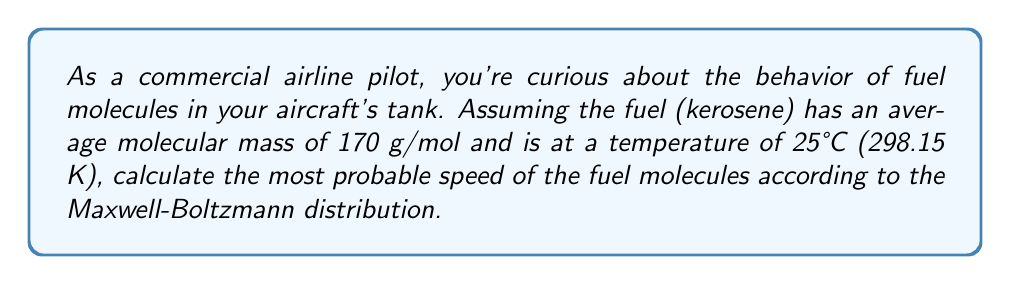Provide a solution to this math problem. To solve this problem, we'll use the Maxwell-Boltzmann distribution to find the most probable speed of the fuel molecules. Let's break it down step-by-step:

1. The formula for the most probable speed ($v_p$) in the Maxwell-Boltzmann distribution is:

   $$v_p = \sqrt{\frac{2k_BT}{m}}$$

   Where:
   $k_B$ is the Boltzmann constant
   $T$ is the temperature in Kelvin
   $m$ is the mass of a single molecule

2. We know:
   - Temperature, $T = 298.15$ K
   - Average molecular mass = 170 g/mol

3. First, let's convert the molecular mass to kilograms per molecule:
   $$m = \frac{170 \text{ g/mol}}{6.022 \times 10^{23} \text{ molecules/mol}} = 2.823 \times 10^{-22} \text{ kg/molecule}$$

4. Now, let's plug in the values:
   - $k_B = 1.380649 \times 10^{-23}$ J/K
   - $T = 298.15$ K
   - $m = 2.823 \times 10^{-22}$ kg

5. Calculating $v_p$:

   $$v_p = \sqrt{\frac{2(1.380649 \times 10^{-23} \text{ J/K})(298.15 \text{ K})}{2.823 \times 10^{-22} \text{ kg}}}$$

6. Simplifying:

   $$v_p = \sqrt{\frac{8.23 \times 10^{-21}}{2.823 \times 10^{-22}}}$$

   $$v_p = \sqrt{29.15} \text{ m/s}$$

7. Final calculation:

   $$v_p = 5.40 \text{ m/s}$$
Answer: 5.40 m/s 